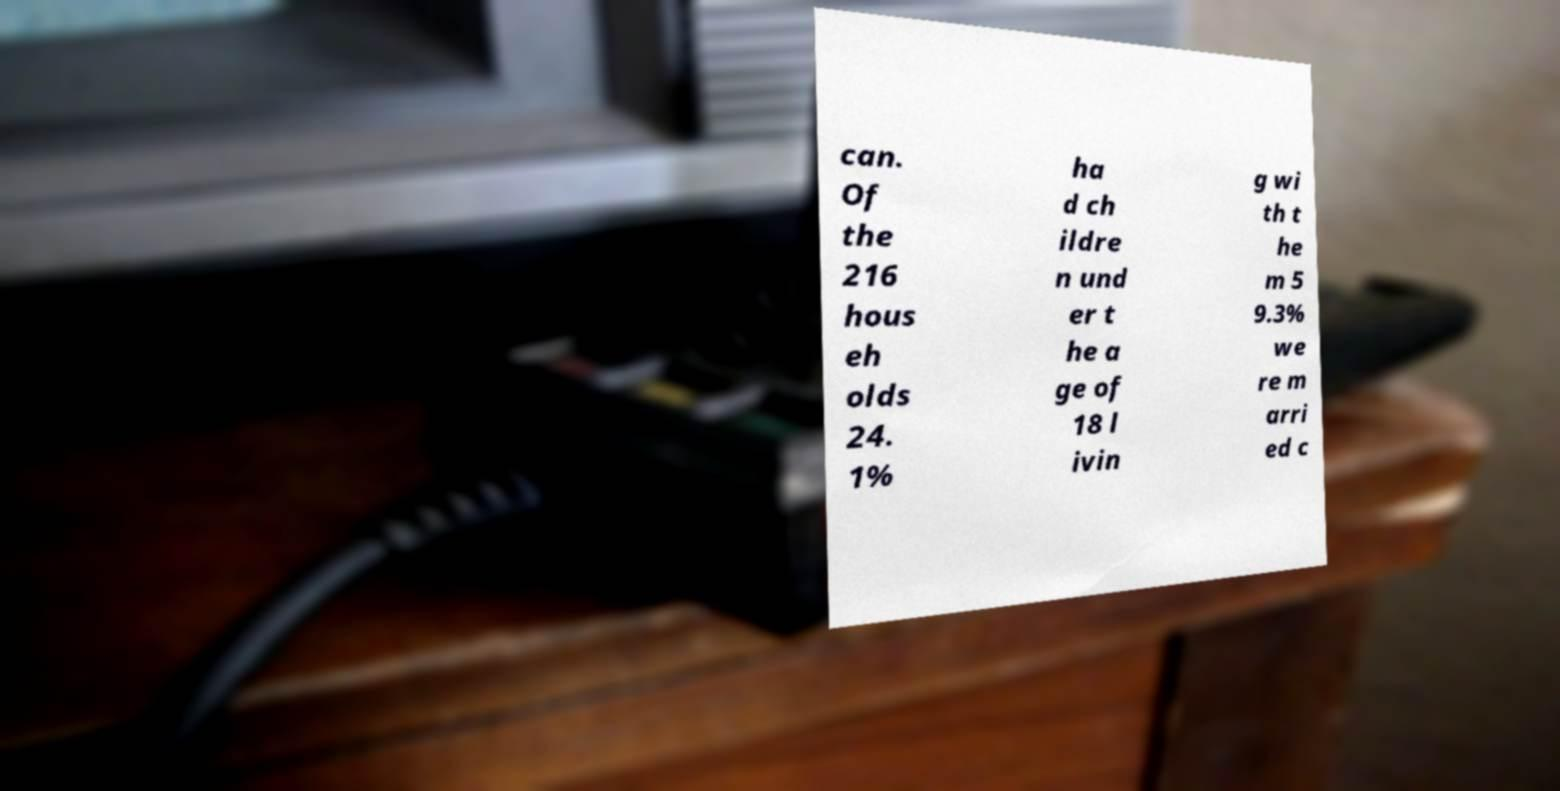Can you read and provide the text displayed in the image?This photo seems to have some interesting text. Can you extract and type it out for me? can. Of the 216 hous eh olds 24. 1% ha d ch ildre n und er t he a ge of 18 l ivin g wi th t he m 5 9.3% we re m arri ed c 